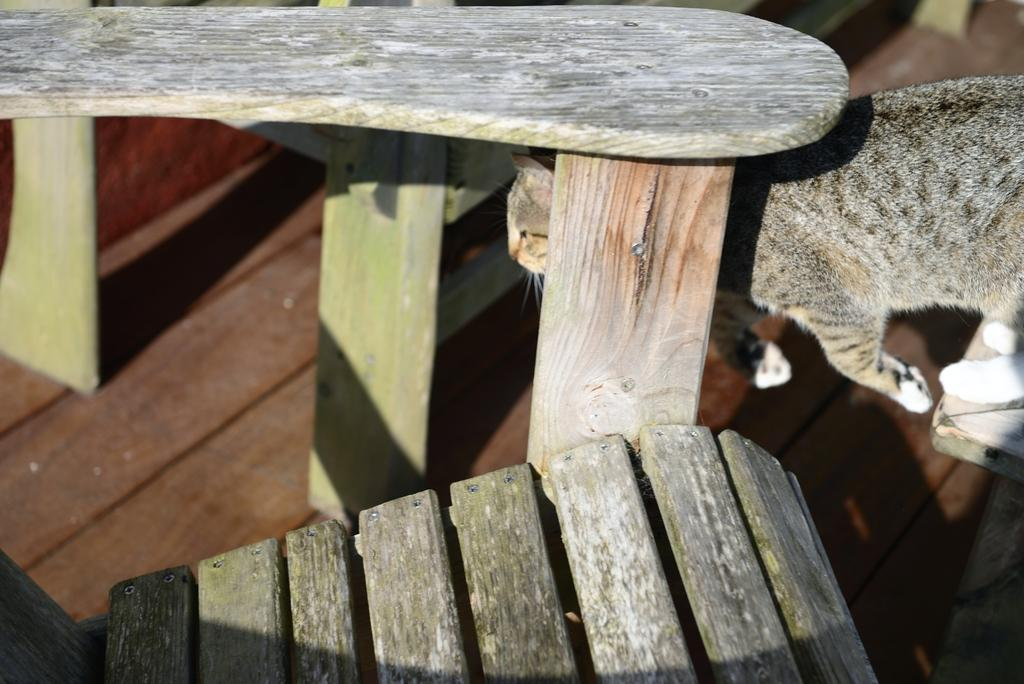What type of furniture is present at the top of the image? There is a table in the image, located at the top. What type of furniture is present at the bottom of the image? There is a chair in the image, located at the bottom. What type of animal is present in the image? There is a cat in the image, located towards the right side. What type of music is the cat playing in the image? There is no music or musical instrument present in the image, so the cat cannot be playing any music. 